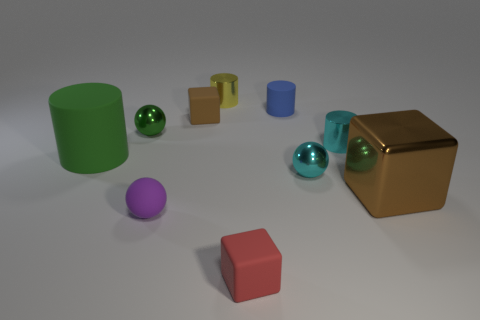Is the number of cyan metal things that are in front of the green rubber cylinder greater than the number of cyan metallic cubes?
Make the answer very short. Yes. There is a tiny red thing; does it have the same shape as the big object that is to the right of the large green matte thing?
Ensure brevity in your answer.  Yes. Is there a big red metallic sphere?
Offer a very short reply. No. What number of tiny things are either purple rubber objects or blue matte things?
Offer a very short reply. 2. Are there more cylinders that are behind the brown matte thing than large objects behind the large brown thing?
Your answer should be very brief. Yes. Is the tiny blue object made of the same material as the block that is behind the small green sphere?
Offer a very short reply. Yes. What color is the big shiny block?
Offer a terse response. Brown. What shape is the green object right of the large green object?
Offer a terse response. Sphere. What number of red objects are either blocks or metal objects?
Your response must be concise. 1. There is a large cylinder that is made of the same material as the tiny purple sphere; what is its color?
Ensure brevity in your answer.  Green. 